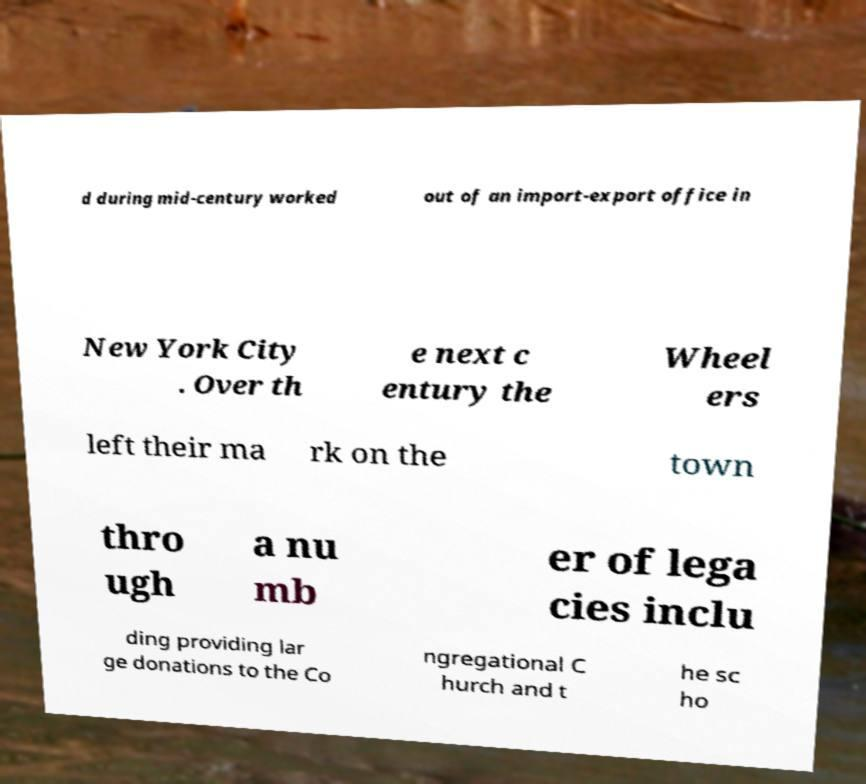I need the written content from this picture converted into text. Can you do that? d during mid-century worked out of an import-export office in New York City . Over th e next c entury the Wheel ers left their ma rk on the town thro ugh a nu mb er of lega cies inclu ding providing lar ge donations to the Co ngregational C hurch and t he sc ho 